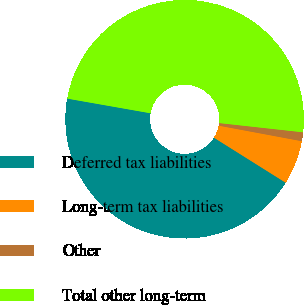Convert chart. <chart><loc_0><loc_0><loc_500><loc_500><pie_chart><fcel>Deferred tax liabilities<fcel>Long-term tax liabilities<fcel>Other<fcel>Total other long-term<nl><fcel>43.85%<fcel>5.98%<fcel>1.2%<fcel>48.97%<nl></chart> 